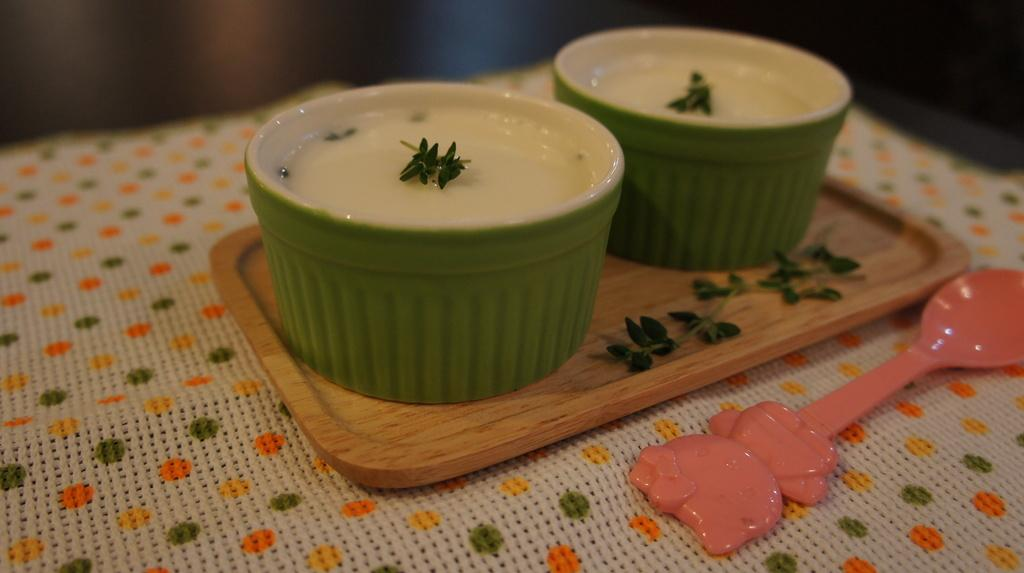What type of furniture is present in the image? There is a table in the image. How is the table decorated or covered? The table is covered with a cloth. What can be seen on top of the table? There is a plate on the table, and two bowls and a spoon are on the plate. What type of train can be seen passing by in the image? There is no train present in the image; it only features a table with a cloth, a plate, two bowls, and a spoon. 